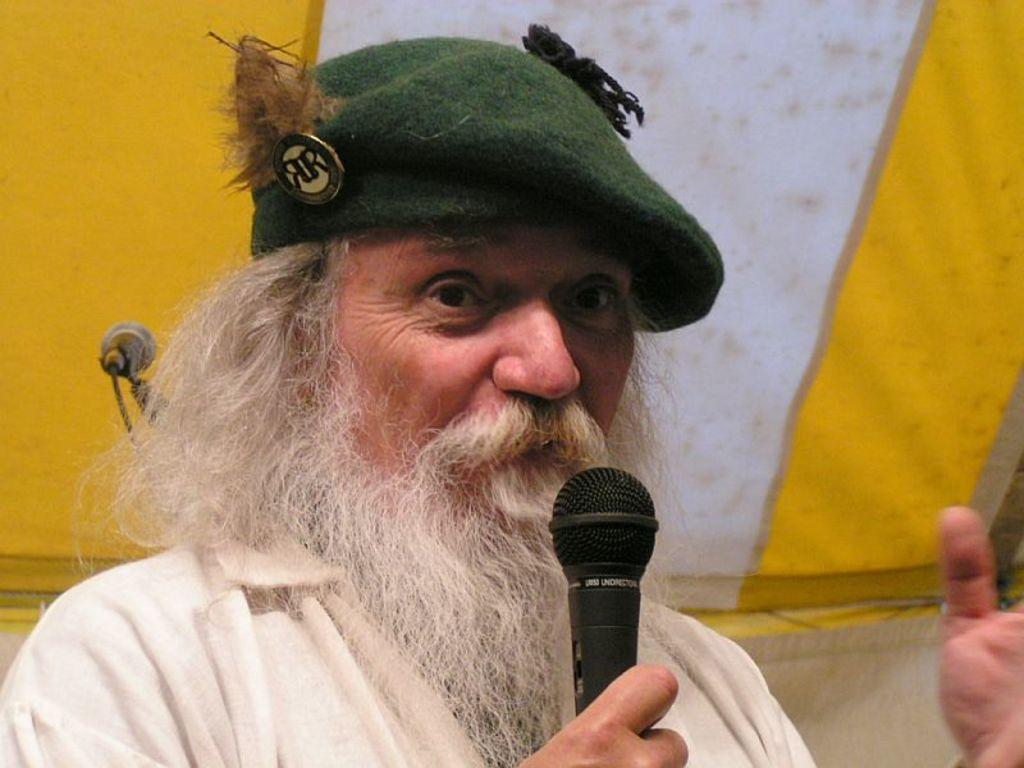What is the man in the image holding in his hand? The man is holding a mic in his hand. What type of headwear is the man wearing? The man is wearing a cap. What can be seen in the background of the image? There is a cloth in the background of the image. What colors are present on the cloth in the background? The cloth has white and yellow colors. How many steel beams are supporting the chairs in the image? There are no steel beams or chairs present in the image. 